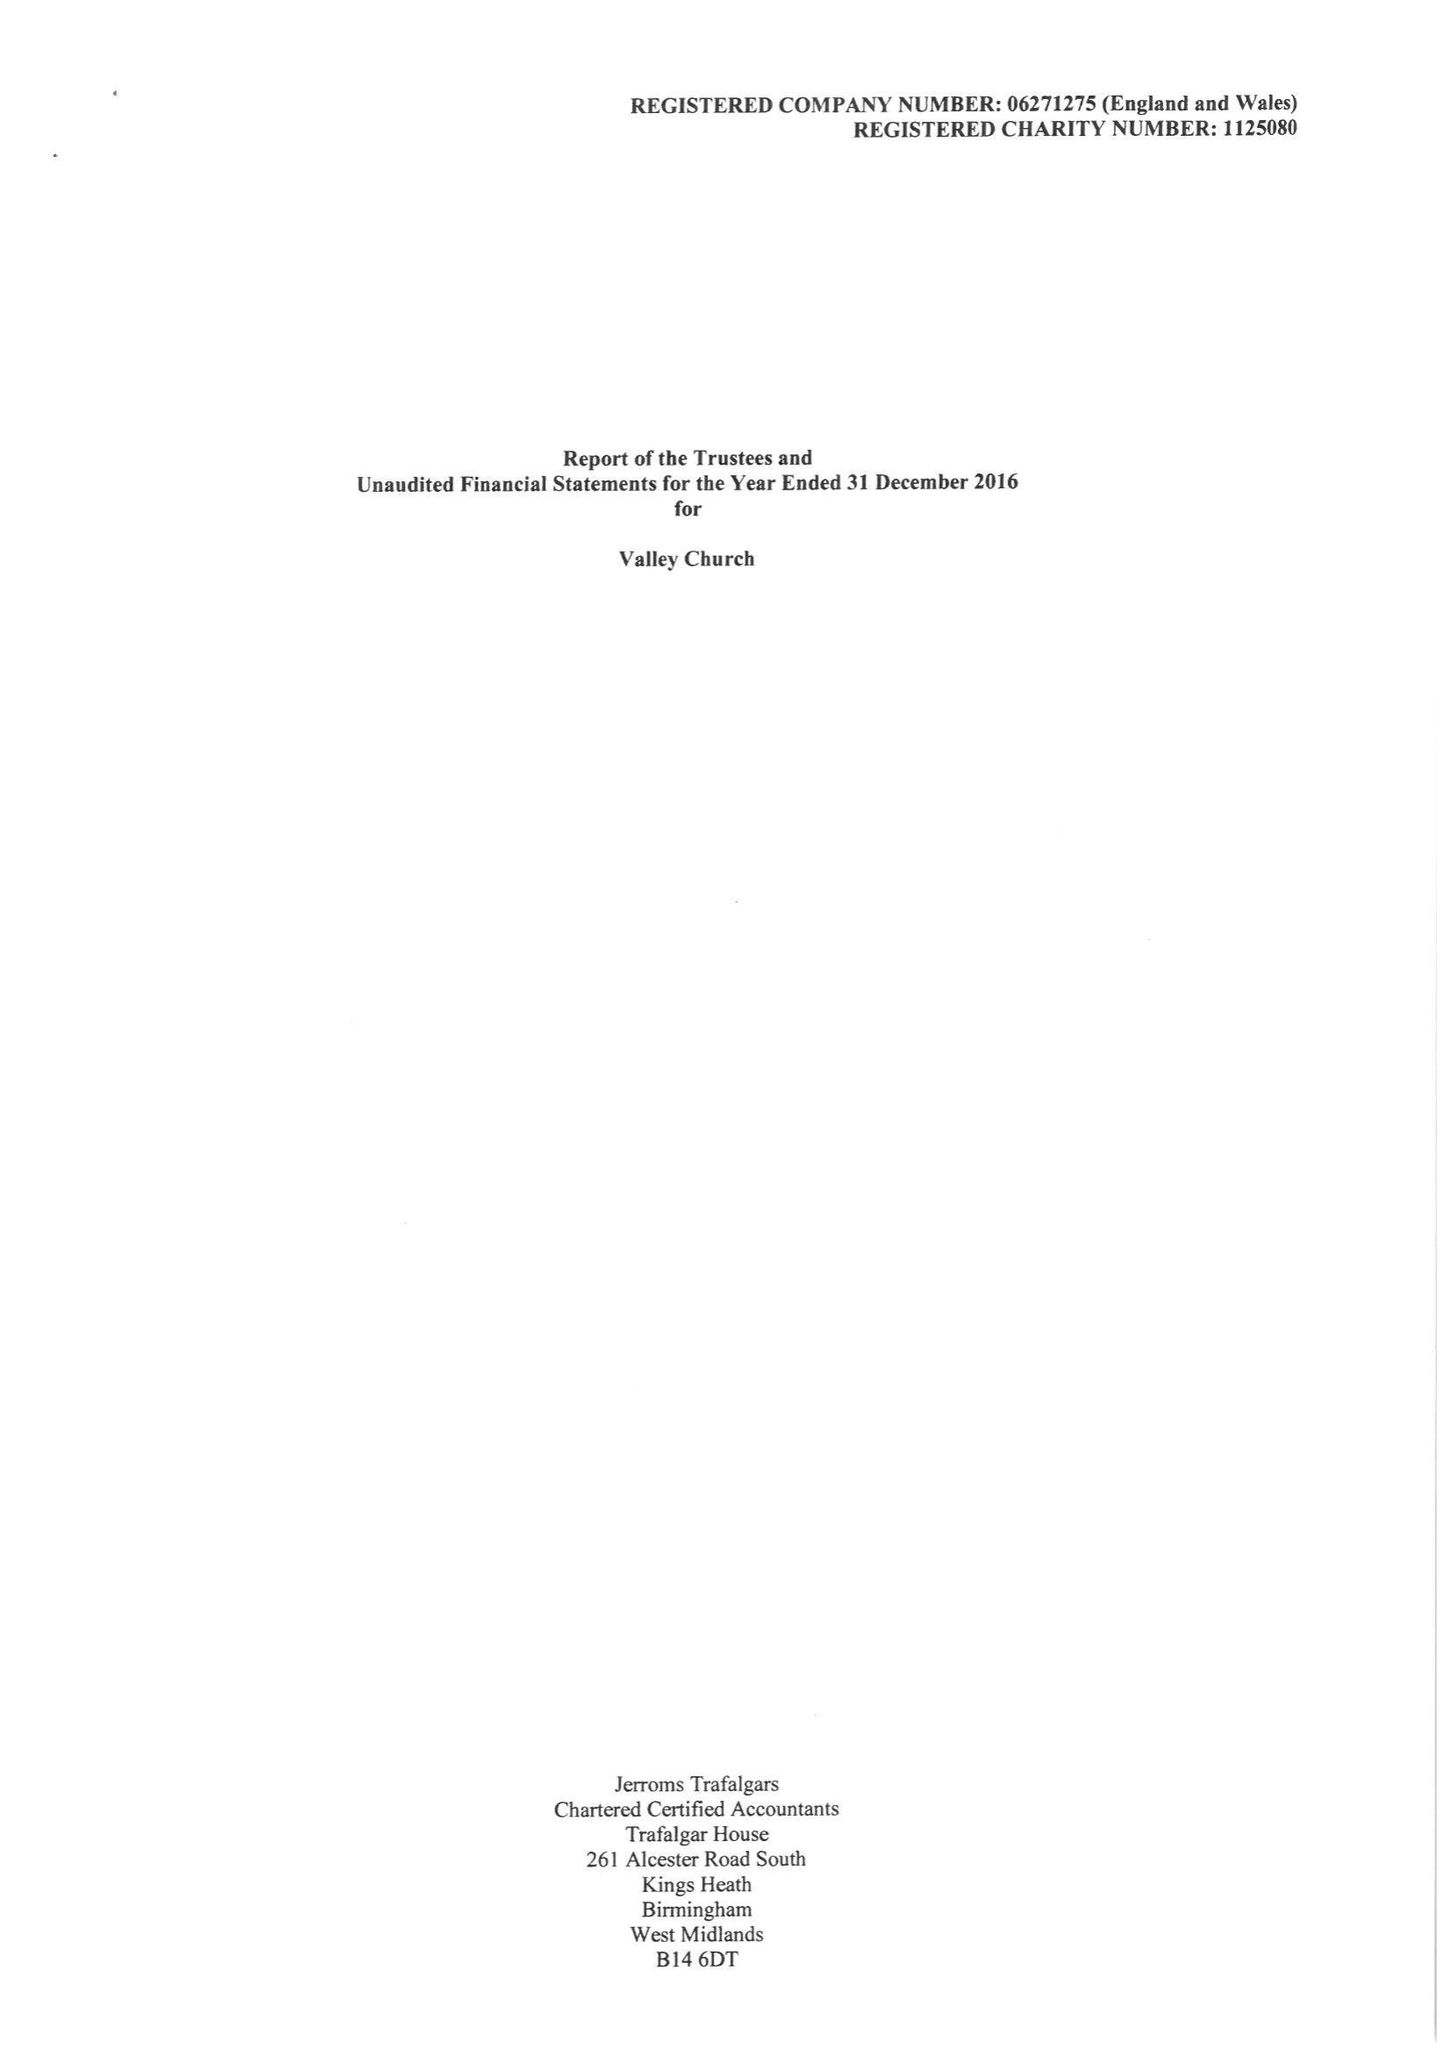What is the value for the charity_number?
Answer the question using a single word or phrase. 1125080 